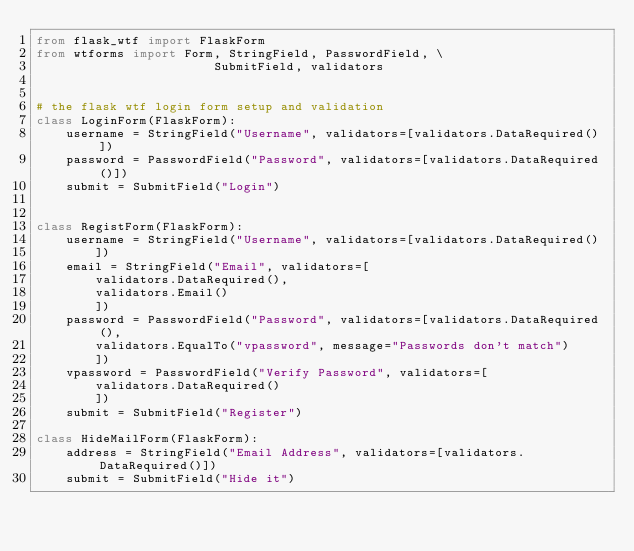Convert code to text. <code><loc_0><loc_0><loc_500><loc_500><_Python_>from flask_wtf import FlaskForm
from wtforms import Form, StringField, PasswordField, \
                        SubmitField, validators

                        
# the flask wtf login form setup and validation
class LoginForm(FlaskForm):
    username = StringField("Username", validators=[validators.DataRequired()])
    password = PasswordField("Password", validators=[validators.DataRequired()])
    submit = SubmitField("Login")


class RegistForm(FlaskForm):
    username = StringField("Username", validators=[validators.DataRequired()
        ])
    email = StringField("Email", validators=[
        validators.DataRequired(), 
        validators.Email()
        ])
    password = PasswordField("Password", validators=[validators.DataRequired(), 
        validators.EqualTo("vpassword", message="Passwords don't match")
        ])
    vpassword = PasswordField("Verify Password", validators=[
        validators.DataRequired()
        ])
    submit = SubmitField("Register")

class HideMailForm(FlaskForm):
    address = StringField("Email Address", validators=[validators.DataRequired()])
    submit = SubmitField("Hide it")</code> 